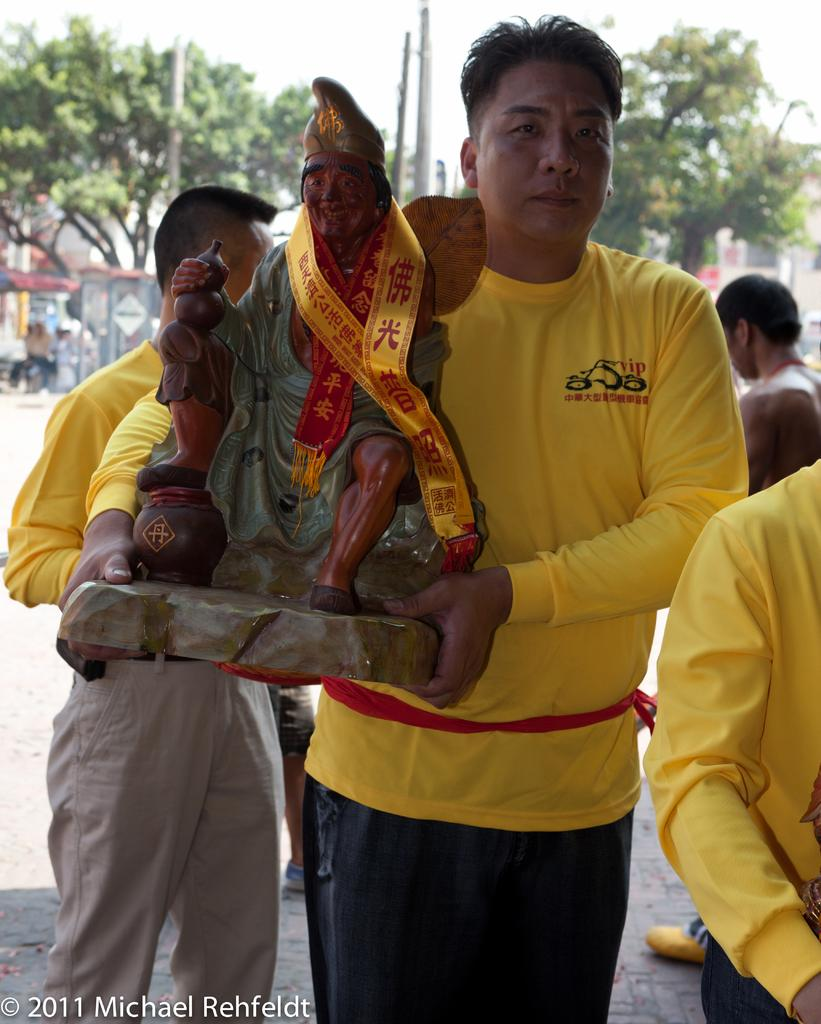What is the man in the image holding? The man is holding an idol in his hands. Are there any other people in the image besides the man? Yes, there are other people standing behind the man. What can be seen in the background of the image? Trees and electrical poles are visible in the image. What type of brush is the man using to paint the calendar in the image? There is no brush or calendar present in the image. Where is the basin located in the image? There is no basin present in the image. 